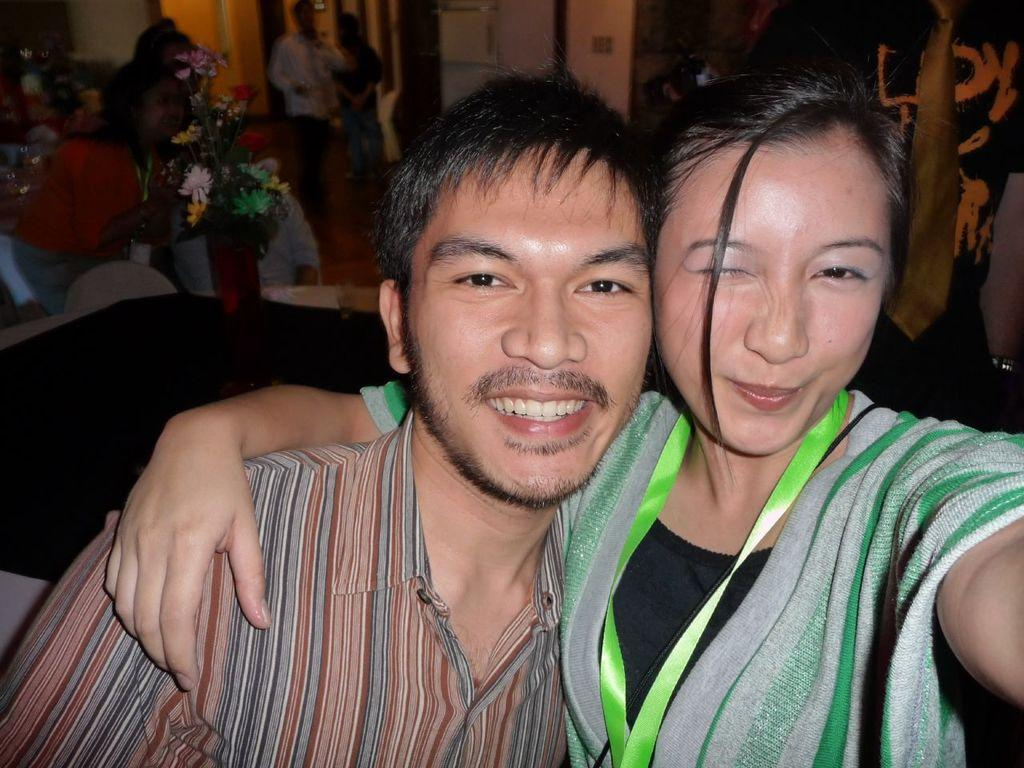How many people are present in the image? There are two persons in the image. What can be seen in the background of the image? There is a group of people in the background of the image. What object is on a table in the image? There is a flower vase on a table in the image. What type of appliance is visible in the image? There is a refrigerator in the image. What other items can be seen in the image? There are other items visible in the image, but their specific details are not mentioned in the provided facts. What type of circle can be seen on the refrigerator in the image? There is no circle visible on the refrigerator in the image. Can you describe the toad that is sitting on the table in the image? There is no toad present in the image; it only features a flower vase on the table. 